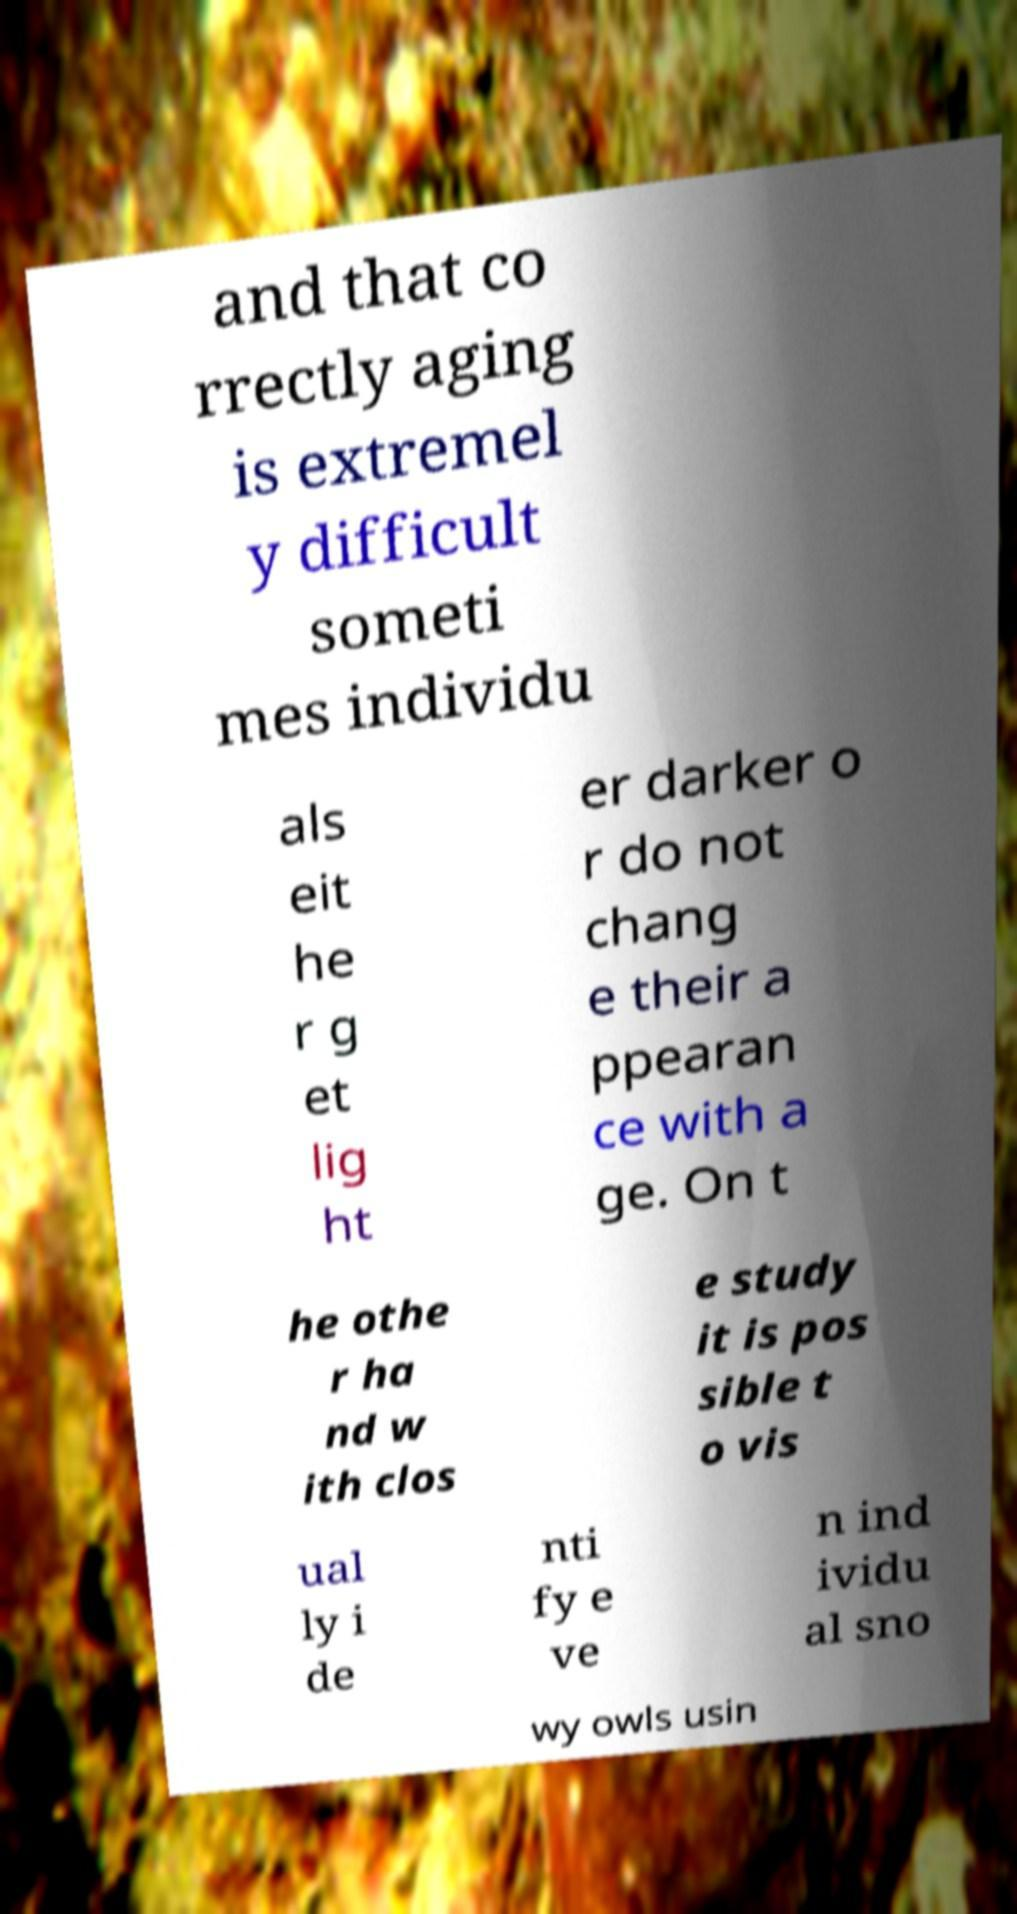Could you assist in decoding the text presented in this image and type it out clearly? and that co rrectly aging is extremel y difficult someti mes individu als eit he r g et lig ht er darker o r do not chang e their a ppearan ce with a ge. On t he othe r ha nd w ith clos e study it is pos sible t o vis ual ly i de nti fy e ve n ind ividu al sno wy owls usin 